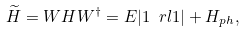Convert formula to latex. <formula><loc_0><loc_0><loc_500><loc_500>\widetilde { H } = W H W ^ { \dagger } = E | 1 \ r l 1 | + H _ { p h } ,</formula> 